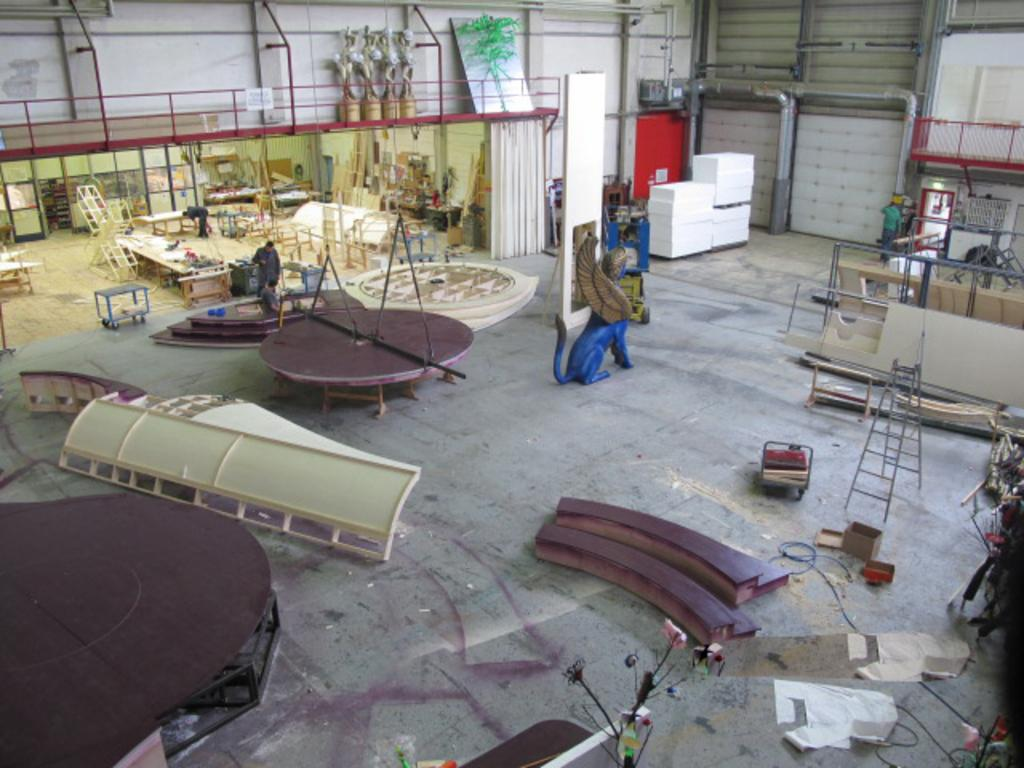What is the main subject of the image? There is a sculpture in the image. What other objects can be seen in the image? There is a ladder, tables, metal objects, a floor, a person, statues, boards, and a wall in the image. What is the person in the image doing? The provided facts do not specify what the person is doing. What type of material are the statues made of? The provided facts do not specify the material of the statues. What type of curtain can be seen hanging from the railway in the image? There is no curtain or railway present in the image. 